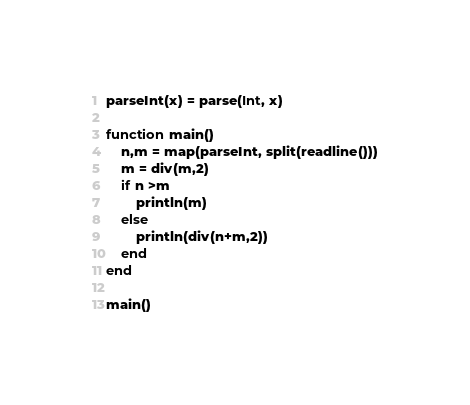Convert code to text. <code><loc_0><loc_0><loc_500><loc_500><_Julia_>parseInt(x) = parse(Int, x)

function main()
	n,m = map(parseInt, split(readline()))
	m = div(m,2)
	if n >m
		println(m)
	else
		println(div(n+m,2))
	end
end

main()</code> 